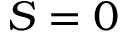<formula> <loc_0><loc_0><loc_500><loc_500>S = 0</formula> 